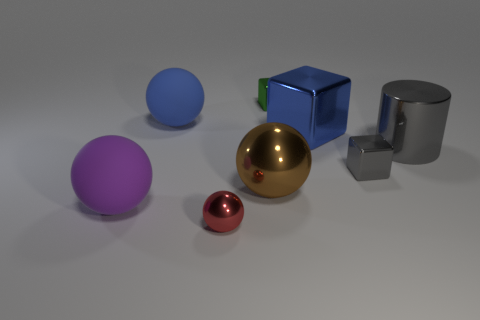There is a thing that is the same color as the big block; what is it made of?
Your answer should be compact. Rubber. How many other objects are there of the same color as the large shiny cylinder?
Provide a short and direct response. 1. Is the material of the small gray cube the same as the big blue object in front of the blue rubber object?
Ensure brevity in your answer.  Yes. There is a large rubber sphere that is in front of the large shiny object that is on the left side of the blue metallic block; what number of big blue metallic cubes are on the right side of it?
Offer a terse response. 1. Are there fewer big blue objects behind the blue shiny object than matte objects left of the gray cube?
Give a very brief answer. Yes. How many other things are the same material as the tiny red ball?
Give a very brief answer. 5. There is a blue ball that is the same size as the gray cylinder; what is its material?
Your response must be concise. Rubber. What number of gray objects are either small balls or shiny objects?
Provide a succinct answer. 2. What color is the big thing that is behind the large gray metal cylinder and to the right of the large blue rubber ball?
Keep it short and to the point. Blue. Do the sphere in front of the large purple matte sphere and the blue object that is left of the small red thing have the same material?
Ensure brevity in your answer.  No. 